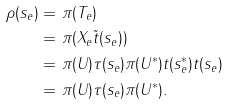Convert formula to latex. <formula><loc_0><loc_0><loc_500><loc_500>\rho ( s _ { e } ) = & \ \pi ( T _ { e } ) \\ = & \ \pi ( X _ { e } \tilde { t } ( s _ { e } ) ) \\ = & \ \pi ( U ) \tau ( s _ { e } ) \pi ( U ^ { * } ) t ( s _ { e } ^ { * } ) t ( s _ { e } ) \\ = & \ \pi ( U ) \tau ( s _ { e } ) \pi ( U ^ { * } ) .</formula> 